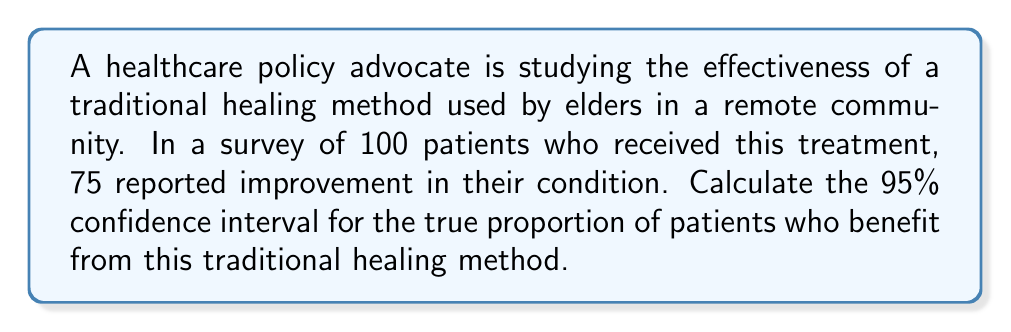Solve this math problem. To calculate the confidence interval, we'll use the following steps:

1. Identify the sample proportion:
   $\hat{p} = \frac{\text{number of successes}}{\text{sample size}} = \frac{75}{100} = 0.75$

2. Calculate the standard error:
   $SE = \sqrt{\frac{\hat{p}(1-\hat{p})}{n}}$
   $SE = \sqrt{\frac{0.75(1-0.75)}{100}} = \sqrt{\frac{0.1875}{100}} = 0.0433$

3. For a 95% confidence interval, use z-score of 1.96:
   $z_{0.025} = 1.96$

4. Calculate the margin of error:
   $ME = z_{0.025} \times SE = 1.96 \times 0.0433 = 0.0849$

5. Compute the confidence interval:
   $CI = \hat{p} \pm ME$
   $CI = 0.75 \pm 0.0849$
   $CI = (0.6651, 0.8349)$

Therefore, we can be 95% confident that the true proportion of patients who benefit from this traditional healing method is between 0.6651 and 0.8349, or approximately 66.51% to 83.49%.
Answer: (0.6651, 0.8349) 